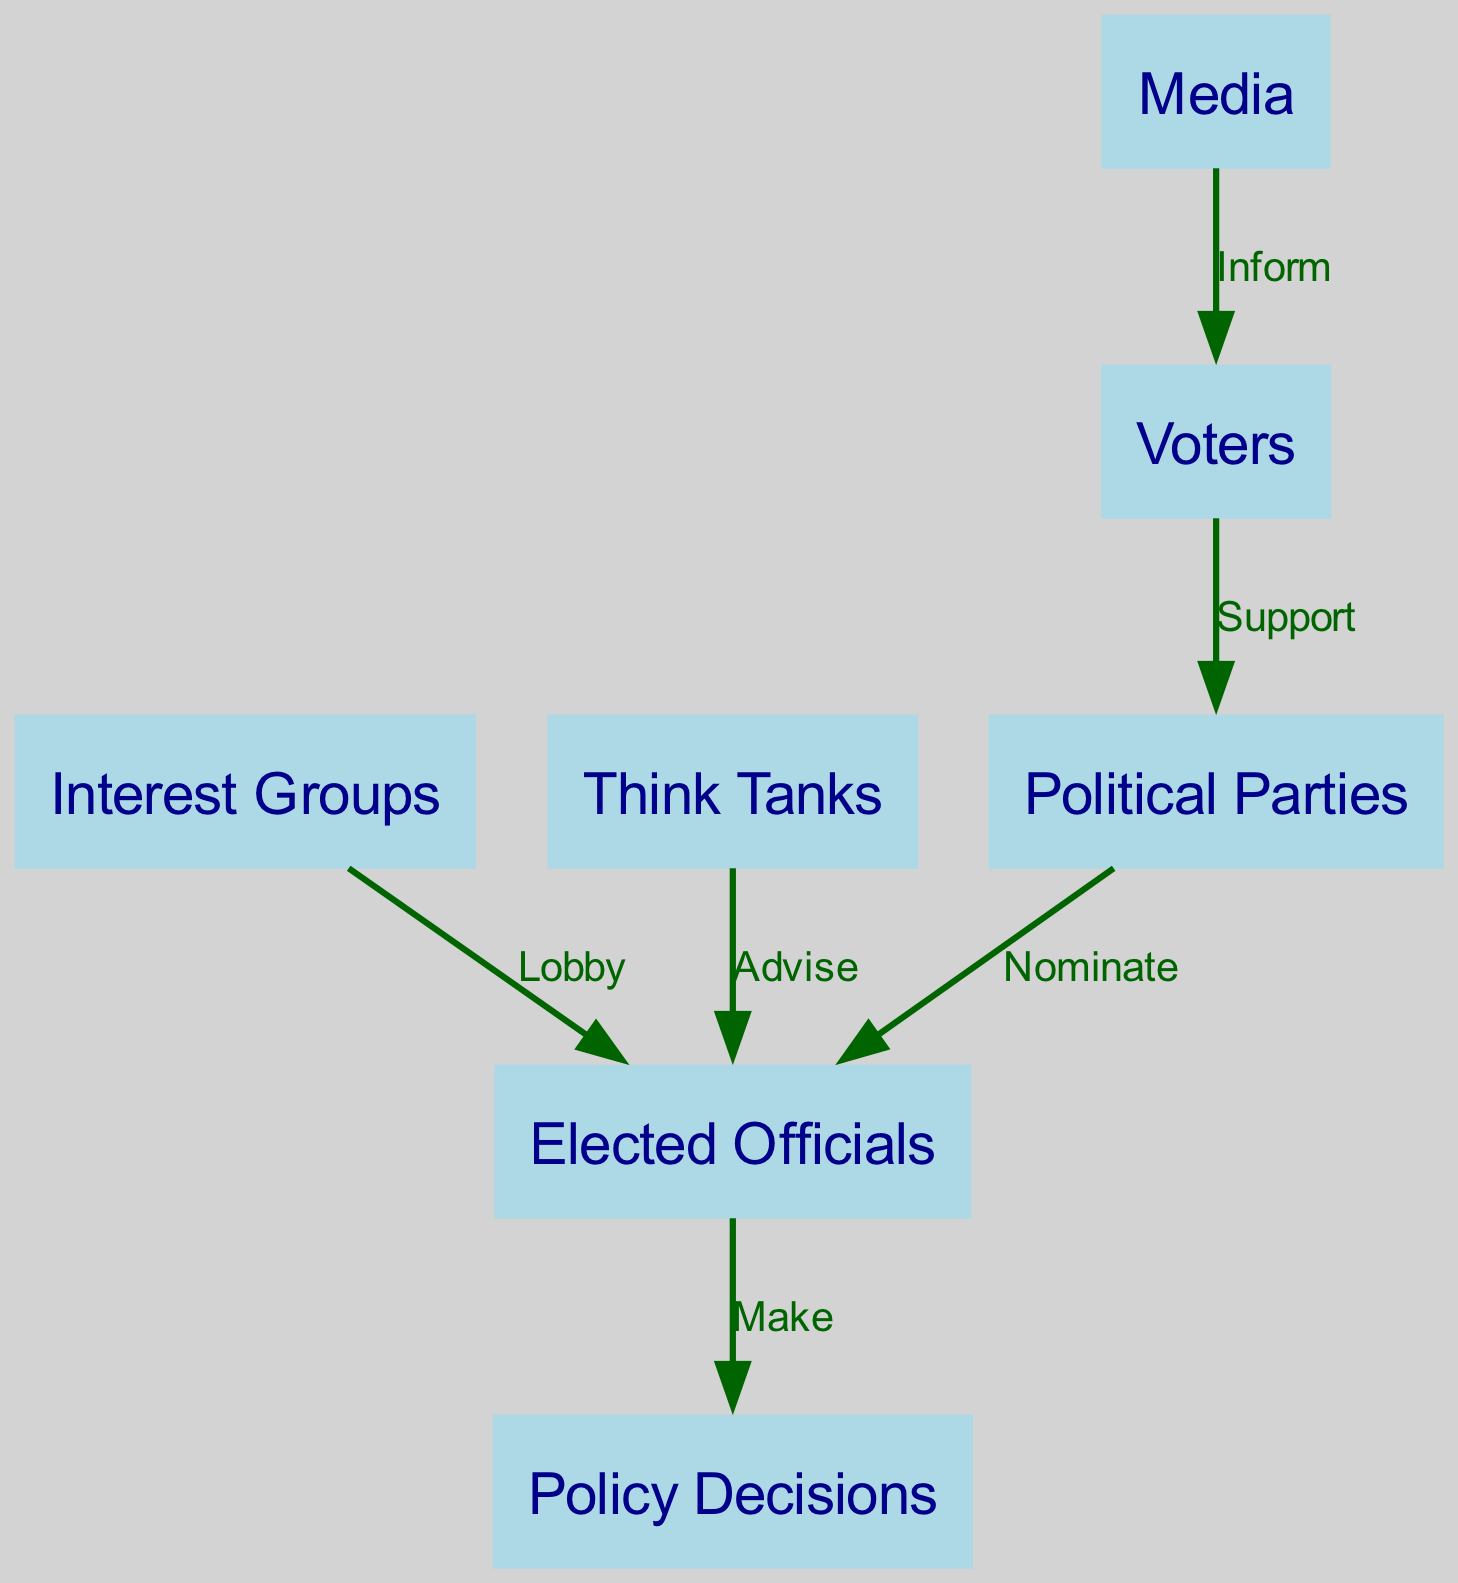What is the total number of nodes in the diagram? The diagram lists the stakeholders involved in the policy-making process. By counting the distinct nodes, we see there are 6 nodes: Voters, Political Parties, Elected Officials, Interest Groups, Media, and Think Tanks.
Answer: 6 What does the Media do in relation to Voters? The edge connecting Media and Voters is labeled "Inform." This label indicates that the Media's role in the policy-making process is to inform Voters.
Answer: Inform Who nominates Elected Officials? The diagram shows an edge from Political Parties to Elected Officials labeled "Nominate." This implies that Political Parties are responsible for nominating Elected Officials.
Answer: Political Parties What is the relationship between Elected Officials and Policy Decisions? The edge labeled "Make" connects Elected Officials to Policy Decisions. This indicates that Elected Officials have the responsibility to make Policy Decisions.
Answer: Make How many edges are there in total? The diagram has edges representing various relationships among the stakeholders. By counting the edges, we find there are 6 edges: Support, Nominate, Make, Lobby, Inform, and Advise.
Answer: 6 What is the role of Think Tanks in relation to Elected Officials? The edge leading from Think Tanks to Elected Officials is labeled "Advise." This indicates that Think Tanks provide advice to Elected Officials in the policy-making process.
Answer: Advise Which stakeholders lobbying is directed at Elected Officials? The diagram indicates that Interest Groups lobby Elected Officials, as shown by the edge labeled "Lobby" connecting the two.
Answer: Interest Groups What is the flow of support from Voters? The diagram shows that Voters support Political Parties, indicating that Voters are a foundational component in this support-based political structure.
Answer: Support 